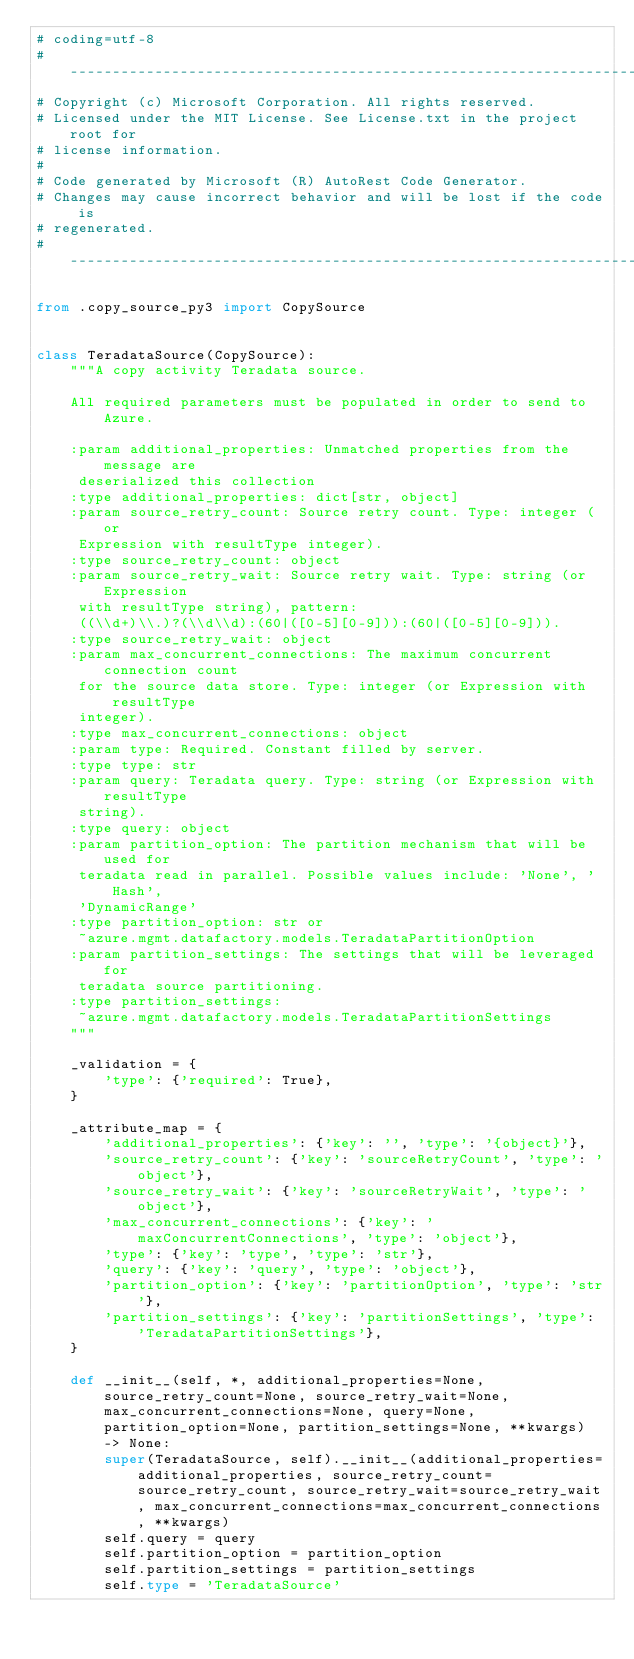Convert code to text. <code><loc_0><loc_0><loc_500><loc_500><_Python_># coding=utf-8
# --------------------------------------------------------------------------
# Copyright (c) Microsoft Corporation. All rights reserved.
# Licensed under the MIT License. See License.txt in the project root for
# license information.
#
# Code generated by Microsoft (R) AutoRest Code Generator.
# Changes may cause incorrect behavior and will be lost if the code is
# regenerated.
# --------------------------------------------------------------------------

from .copy_source_py3 import CopySource


class TeradataSource(CopySource):
    """A copy activity Teradata source.

    All required parameters must be populated in order to send to Azure.

    :param additional_properties: Unmatched properties from the message are
     deserialized this collection
    :type additional_properties: dict[str, object]
    :param source_retry_count: Source retry count. Type: integer (or
     Expression with resultType integer).
    :type source_retry_count: object
    :param source_retry_wait: Source retry wait. Type: string (or Expression
     with resultType string), pattern:
     ((\\d+)\\.)?(\\d\\d):(60|([0-5][0-9])):(60|([0-5][0-9])).
    :type source_retry_wait: object
    :param max_concurrent_connections: The maximum concurrent connection count
     for the source data store. Type: integer (or Expression with resultType
     integer).
    :type max_concurrent_connections: object
    :param type: Required. Constant filled by server.
    :type type: str
    :param query: Teradata query. Type: string (or Expression with resultType
     string).
    :type query: object
    :param partition_option: The partition mechanism that will be used for
     teradata read in parallel. Possible values include: 'None', 'Hash',
     'DynamicRange'
    :type partition_option: str or
     ~azure.mgmt.datafactory.models.TeradataPartitionOption
    :param partition_settings: The settings that will be leveraged for
     teradata source partitioning.
    :type partition_settings:
     ~azure.mgmt.datafactory.models.TeradataPartitionSettings
    """

    _validation = {
        'type': {'required': True},
    }

    _attribute_map = {
        'additional_properties': {'key': '', 'type': '{object}'},
        'source_retry_count': {'key': 'sourceRetryCount', 'type': 'object'},
        'source_retry_wait': {'key': 'sourceRetryWait', 'type': 'object'},
        'max_concurrent_connections': {'key': 'maxConcurrentConnections', 'type': 'object'},
        'type': {'key': 'type', 'type': 'str'},
        'query': {'key': 'query', 'type': 'object'},
        'partition_option': {'key': 'partitionOption', 'type': 'str'},
        'partition_settings': {'key': 'partitionSettings', 'type': 'TeradataPartitionSettings'},
    }

    def __init__(self, *, additional_properties=None, source_retry_count=None, source_retry_wait=None, max_concurrent_connections=None, query=None, partition_option=None, partition_settings=None, **kwargs) -> None:
        super(TeradataSource, self).__init__(additional_properties=additional_properties, source_retry_count=source_retry_count, source_retry_wait=source_retry_wait, max_concurrent_connections=max_concurrent_connections, **kwargs)
        self.query = query
        self.partition_option = partition_option
        self.partition_settings = partition_settings
        self.type = 'TeradataSource'
</code> 